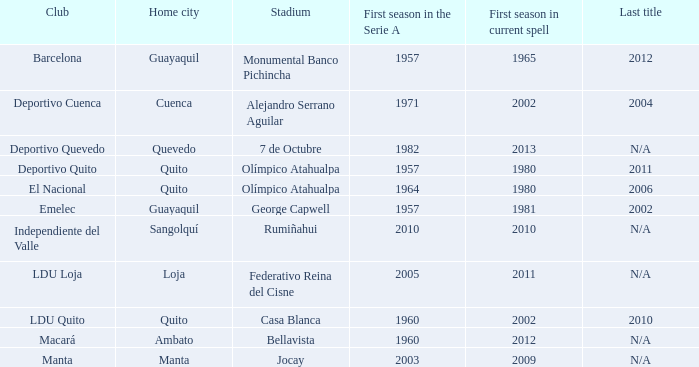Name the most for first season in the serie a for 7 de octubre 1982.0. 